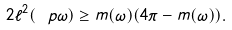<formula> <loc_0><loc_0><loc_500><loc_500>2 \ell ^ { 2 } ( \ p \omega ) \geq m ( \omega ) ( 4 \pi - m ( \omega ) ) .</formula> 